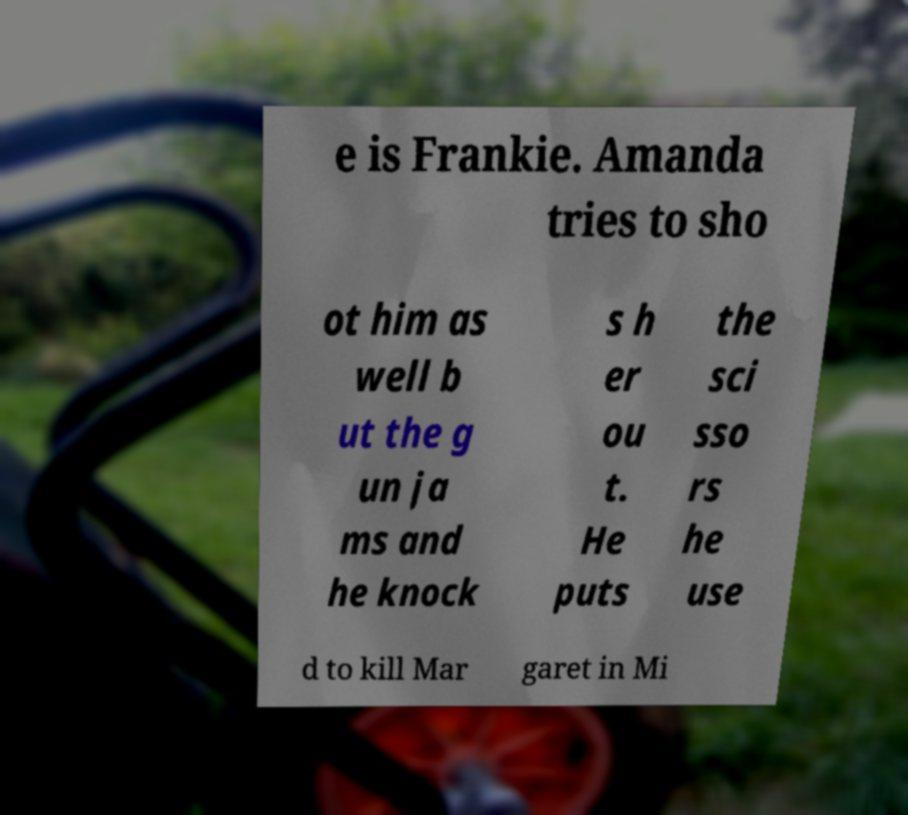There's text embedded in this image that I need extracted. Can you transcribe it verbatim? e is Frankie. Amanda tries to sho ot him as well b ut the g un ja ms and he knock s h er ou t. He puts the sci sso rs he use d to kill Mar garet in Mi 